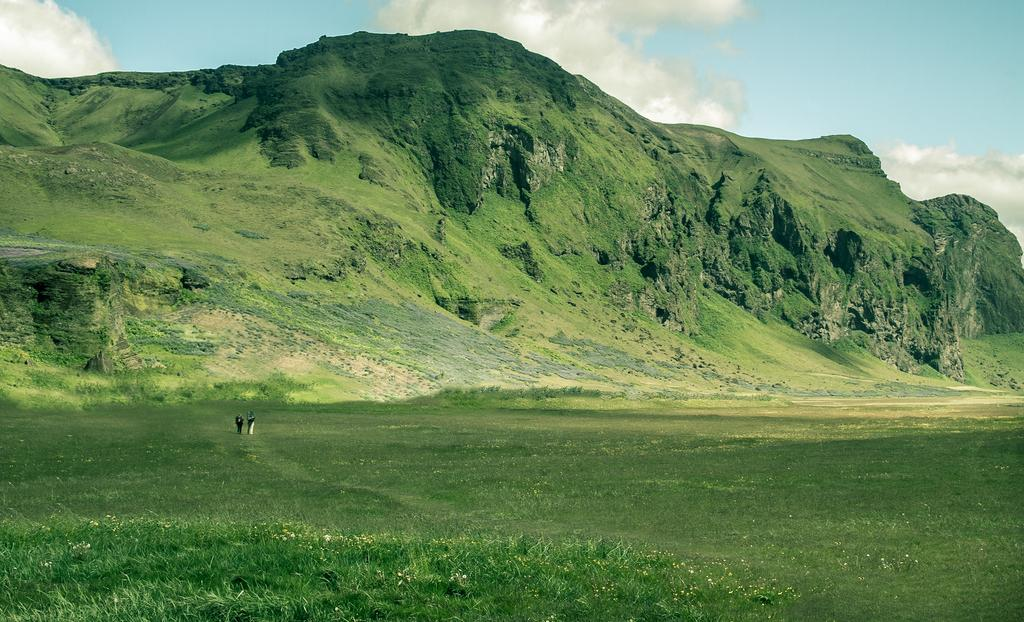What type of landscape can be seen in the image? There are hills in the image. What part of the natural environment is visible in the image? The sky is visible in the image. What type of vegetation is present at the bottom of the image? There is grass at the bottom of the image. Are there any living beings in the image? Yes, there are people in the image. What color is the thread used to sew the rain in the image? There is no rain or thread present in the image. 